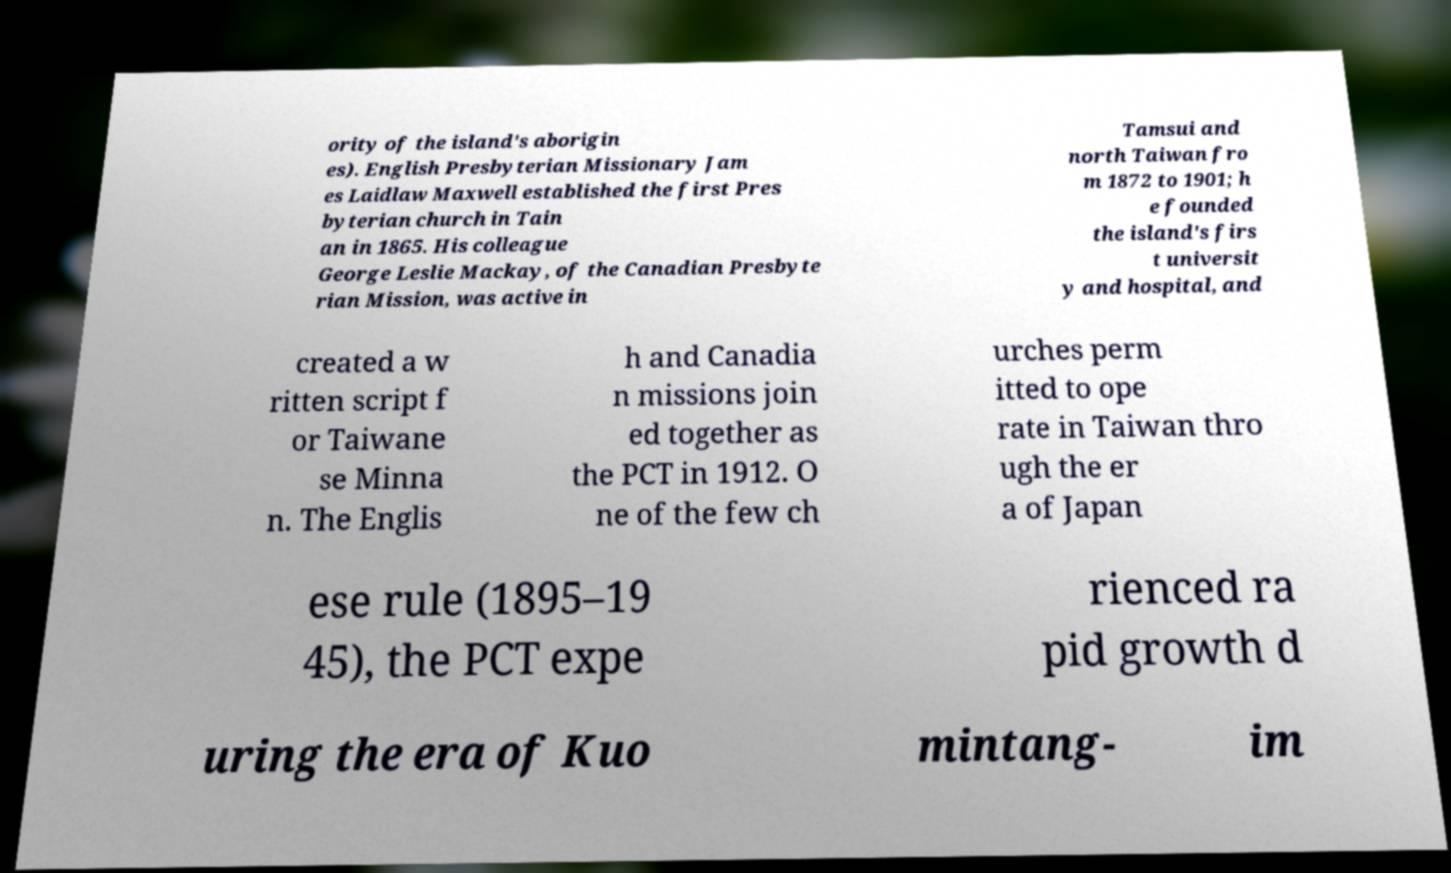Could you assist in decoding the text presented in this image and type it out clearly? ority of the island's aborigin es). English Presbyterian Missionary Jam es Laidlaw Maxwell established the first Pres byterian church in Tain an in 1865. His colleague George Leslie Mackay, of the Canadian Presbyte rian Mission, was active in Tamsui and north Taiwan fro m 1872 to 1901; h e founded the island's firs t universit y and hospital, and created a w ritten script f or Taiwane se Minna n. The Englis h and Canadia n missions join ed together as the PCT in 1912. O ne of the few ch urches perm itted to ope rate in Taiwan thro ugh the er a of Japan ese rule (1895–19 45), the PCT expe rienced ra pid growth d uring the era of Kuo mintang- im 